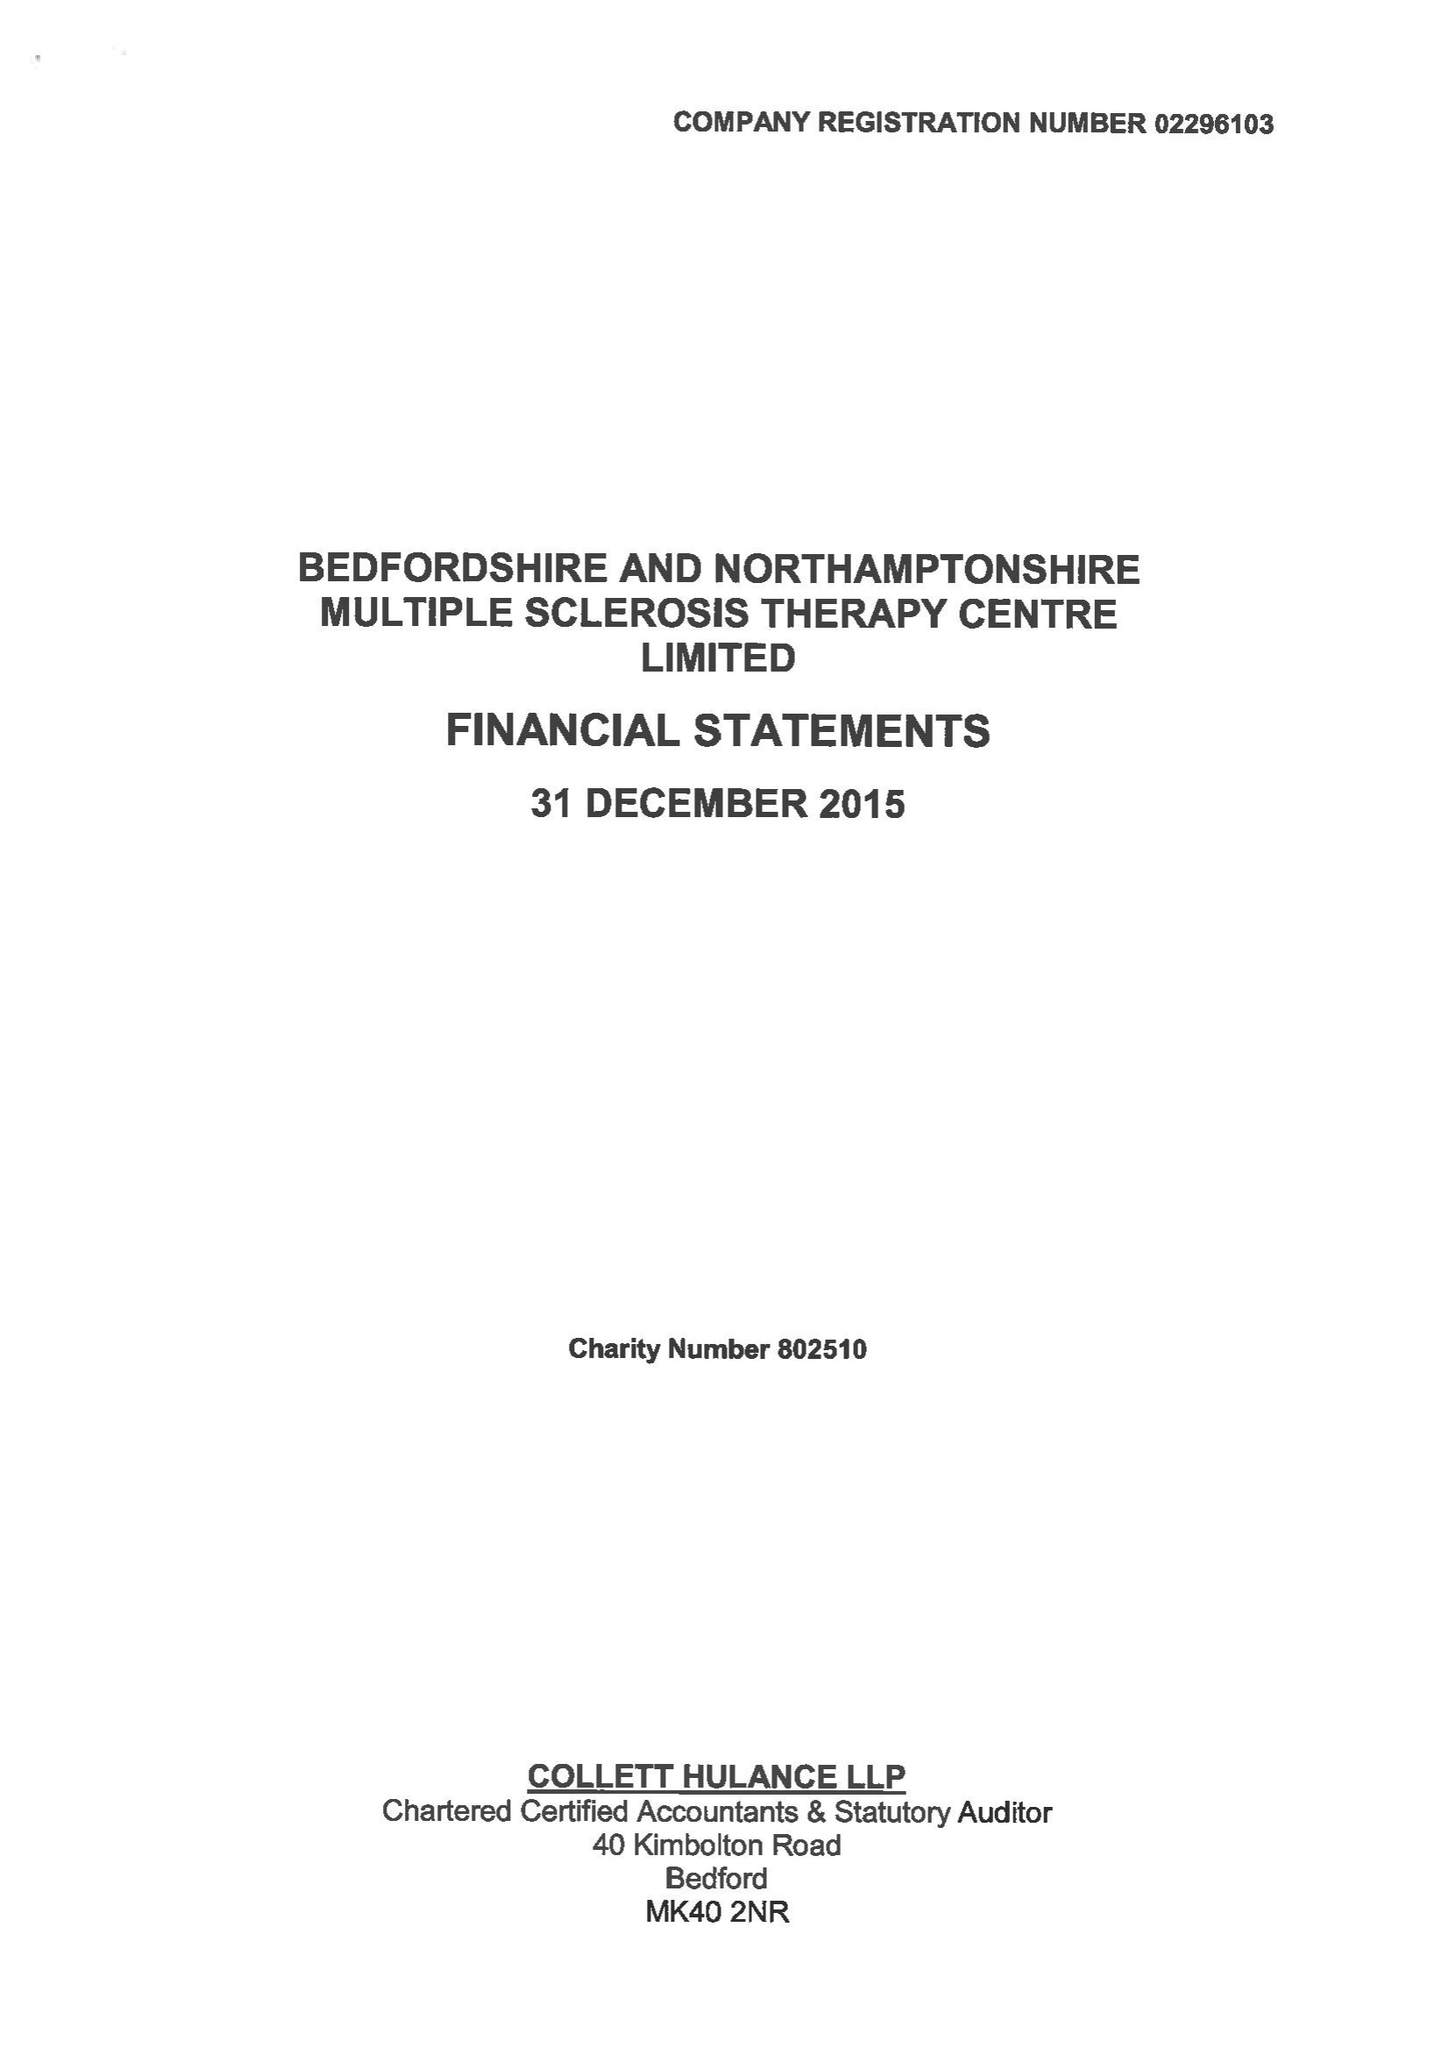What is the value for the charity_name?
Answer the question using a single word or phrase. Bedfordshire and Northamptonshire Multiple Sclerosis Therapy Centre Ltd. 